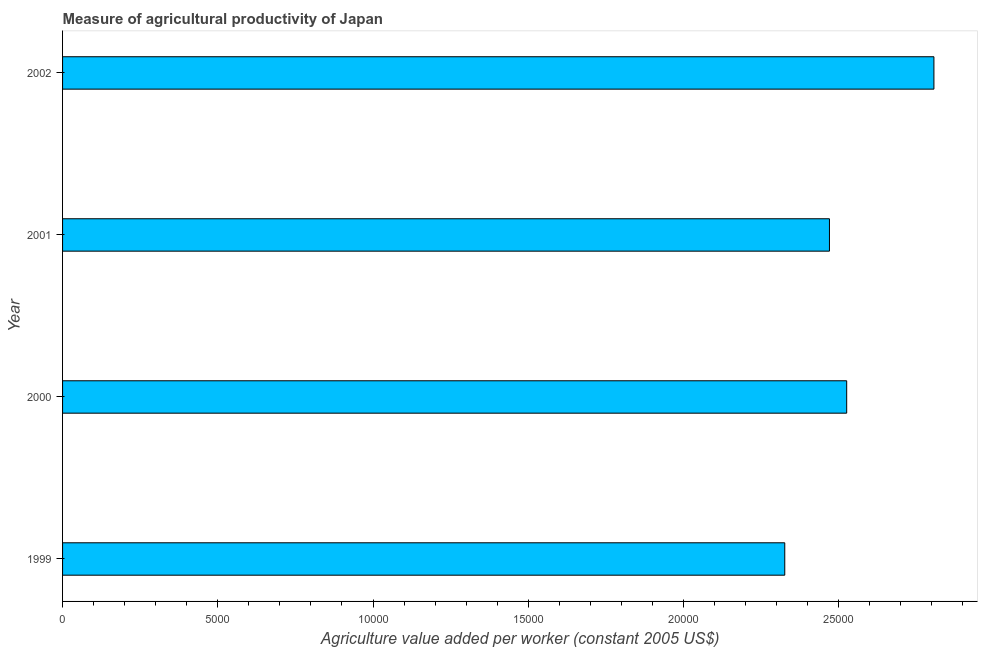Does the graph contain any zero values?
Your response must be concise. No. What is the title of the graph?
Provide a succinct answer. Measure of agricultural productivity of Japan. What is the label or title of the X-axis?
Provide a succinct answer. Agriculture value added per worker (constant 2005 US$). What is the agriculture value added per worker in 2001?
Provide a succinct answer. 2.47e+04. Across all years, what is the maximum agriculture value added per worker?
Give a very brief answer. 2.81e+04. Across all years, what is the minimum agriculture value added per worker?
Offer a very short reply. 2.33e+04. In which year was the agriculture value added per worker maximum?
Your answer should be very brief. 2002. In which year was the agriculture value added per worker minimum?
Ensure brevity in your answer.  1999. What is the sum of the agriculture value added per worker?
Your answer should be very brief. 1.01e+05. What is the difference between the agriculture value added per worker in 1999 and 2000?
Provide a short and direct response. -1994.58. What is the average agriculture value added per worker per year?
Your answer should be compact. 2.53e+04. What is the median agriculture value added per worker?
Give a very brief answer. 2.50e+04. In how many years, is the agriculture value added per worker greater than 13000 US$?
Make the answer very short. 4. Do a majority of the years between 1999 and 2000 (inclusive) have agriculture value added per worker greater than 27000 US$?
Your response must be concise. No. What is the ratio of the agriculture value added per worker in 2000 to that in 2001?
Provide a short and direct response. 1.02. What is the difference between the highest and the second highest agriculture value added per worker?
Make the answer very short. 2809.82. What is the difference between the highest and the lowest agriculture value added per worker?
Your response must be concise. 4804.4. How many bars are there?
Offer a terse response. 4. What is the difference between two consecutive major ticks on the X-axis?
Keep it short and to the point. 5000. What is the Agriculture value added per worker (constant 2005 US$) in 1999?
Give a very brief answer. 2.33e+04. What is the Agriculture value added per worker (constant 2005 US$) in 2000?
Your answer should be very brief. 2.53e+04. What is the Agriculture value added per worker (constant 2005 US$) in 2001?
Ensure brevity in your answer.  2.47e+04. What is the Agriculture value added per worker (constant 2005 US$) of 2002?
Provide a short and direct response. 2.81e+04. What is the difference between the Agriculture value added per worker (constant 2005 US$) in 1999 and 2000?
Your answer should be very brief. -1994.58. What is the difference between the Agriculture value added per worker (constant 2005 US$) in 1999 and 2001?
Keep it short and to the point. -1439.39. What is the difference between the Agriculture value added per worker (constant 2005 US$) in 1999 and 2002?
Offer a very short reply. -4804.4. What is the difference between the Agriculture value added per worker (constant 2005 US$) in 2000 and 2001?
Give a very brief answer. 555.19. What is the difference between the Agriculture value added per worker (constant 2005 US$) in 2000 and 2002?
Make the answer very short. -2809.82. What is the difference between the Agriculture value added per worker (constant 2005 US$) in 2001 and 2002?
Give a very brief answer. -3365.01. What is the ratio of the Agriculture value added per worker (constant 2005 US$) in 1999 to that in 2000?
Your answer should be compact. 0.92. What is the ratio of the Agriculture value added per worker (constant 2005 US$) in 1999 to that in 2001?
Make the answer very short. 0.94. What is the ratio of the Agriculture value added per worker (constant 2005 US$) in 1999 to that in 2002?
Provide a succinct answer. 0.83. What is the ratio of the Agriculture value added per worker (constant 2005 US$) in 2000 to that in 2002?
Provide a short and direct response. 0.9. 